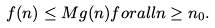Convert formula to latex. <formula><loc_0><loc_0><loc_500><loc_500>f ( n ) \leq M g ( n ) { f o r a l l } n \geq n _ { 0 } .</formula> 